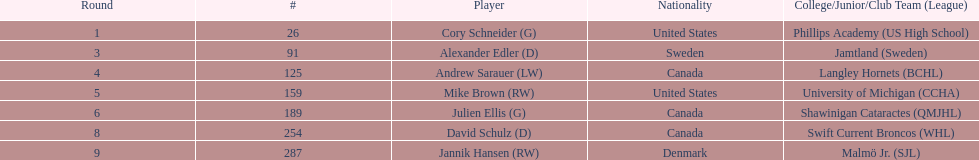What is the designation of the final participant on this diagram? Jannik Hansen (RW). 